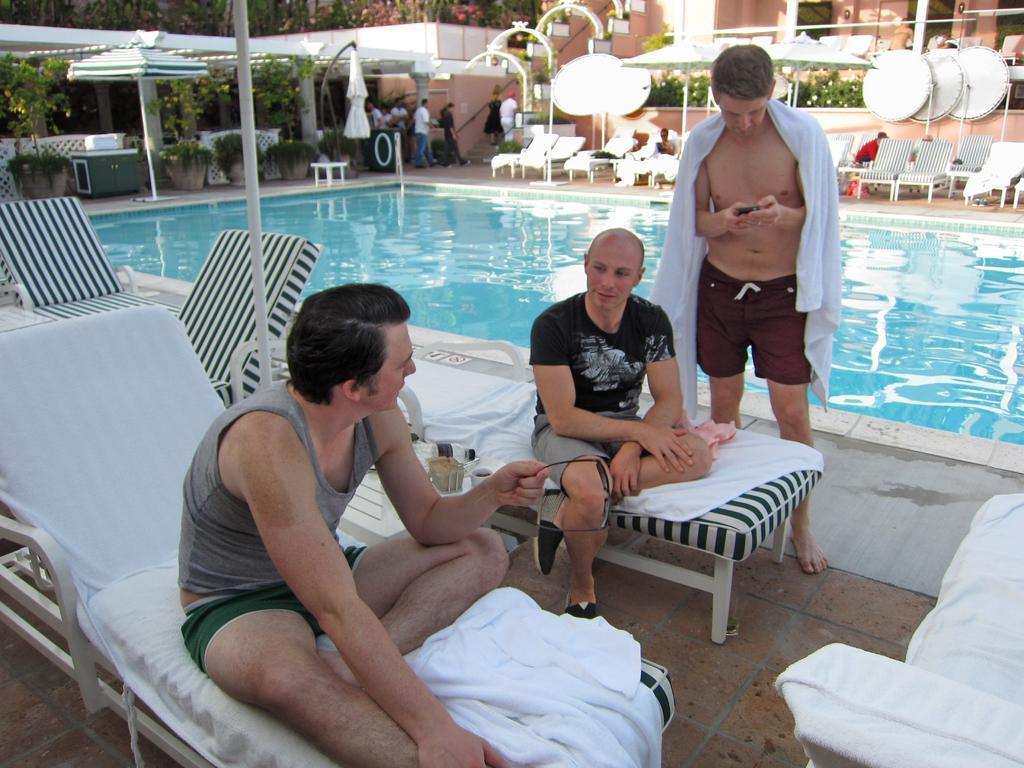How would you summarize this image in a sentence or two? In this picture we can see two friends are sitting on the relaxing chairs and discussing something. Behind there is a man who is looking into the phone. In the background there is a swimming pools and some relaxing chairs. 